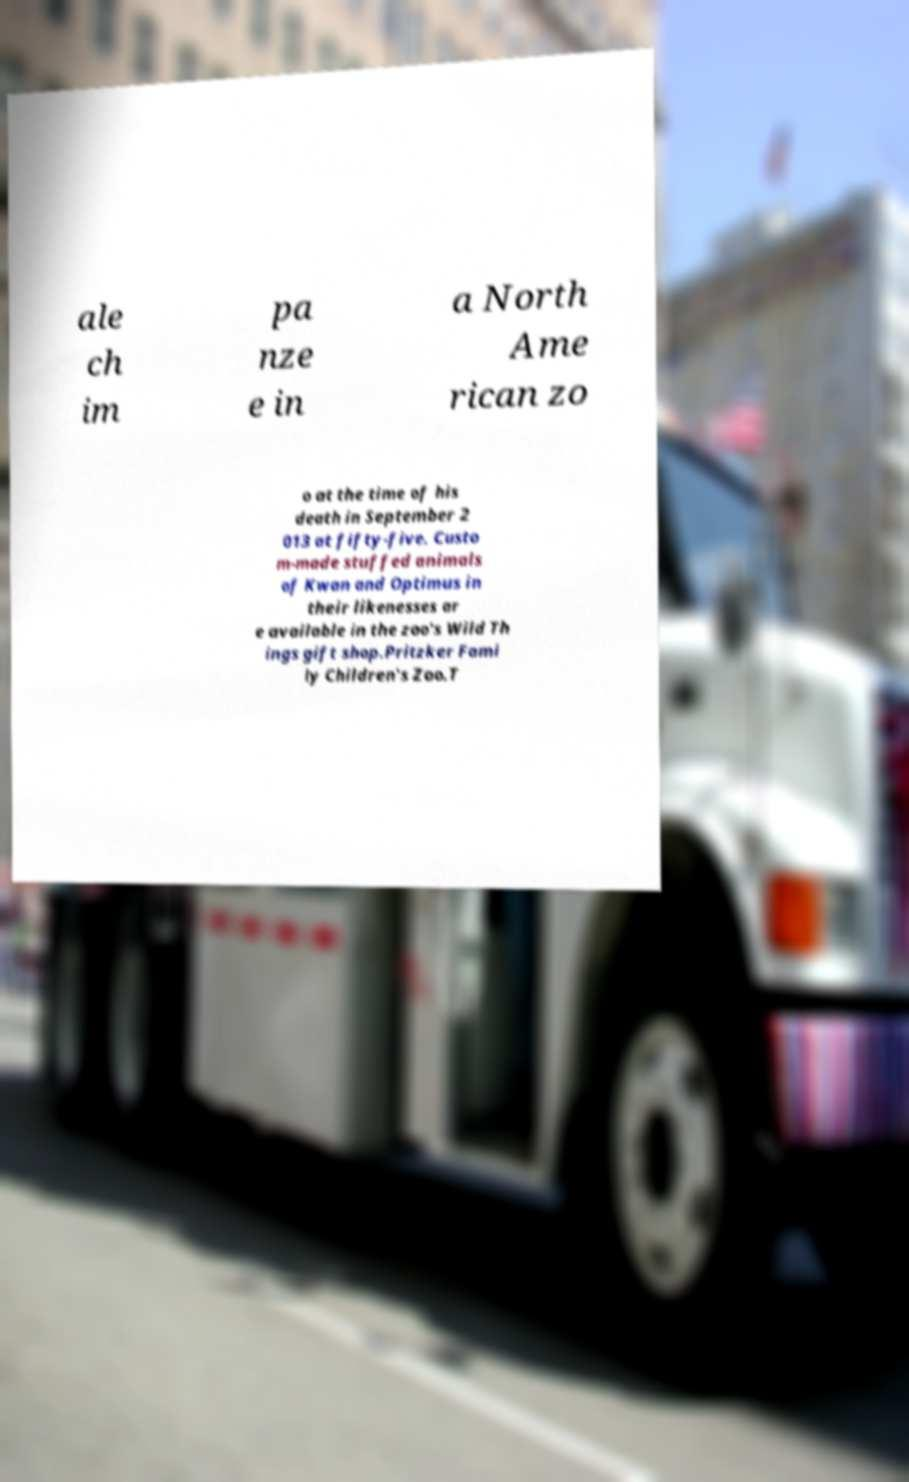Please identify and transcribe the text found in this image. ale ch im pa nze e in a North Ame rican zo o at the time of his death in September 2 013 at fifty-five. Custo m-made stuffed animals of Kwan and Optimus in their likenesses ar e available in the zoo's Wild Th ings gift shop.Pritzker Fami ly Children's Zoo.T 